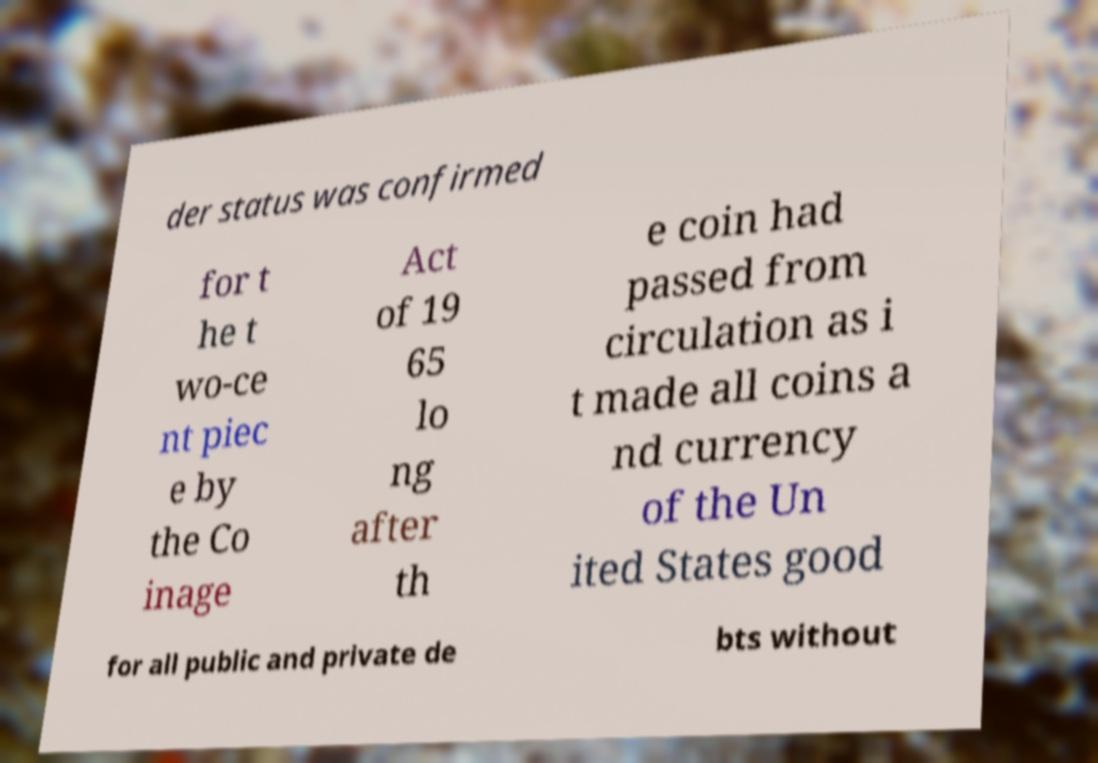There's text embedded in this image that I need extracted. Can you transcribe it verbatim? der status was confirmed for t he t wo-ce nt piec e by the Co inage Act of 19 65 lo ng after th e coin had passed from circulation as i t made all coins a nd currency of the Un ited States good for all public and private de bts without 